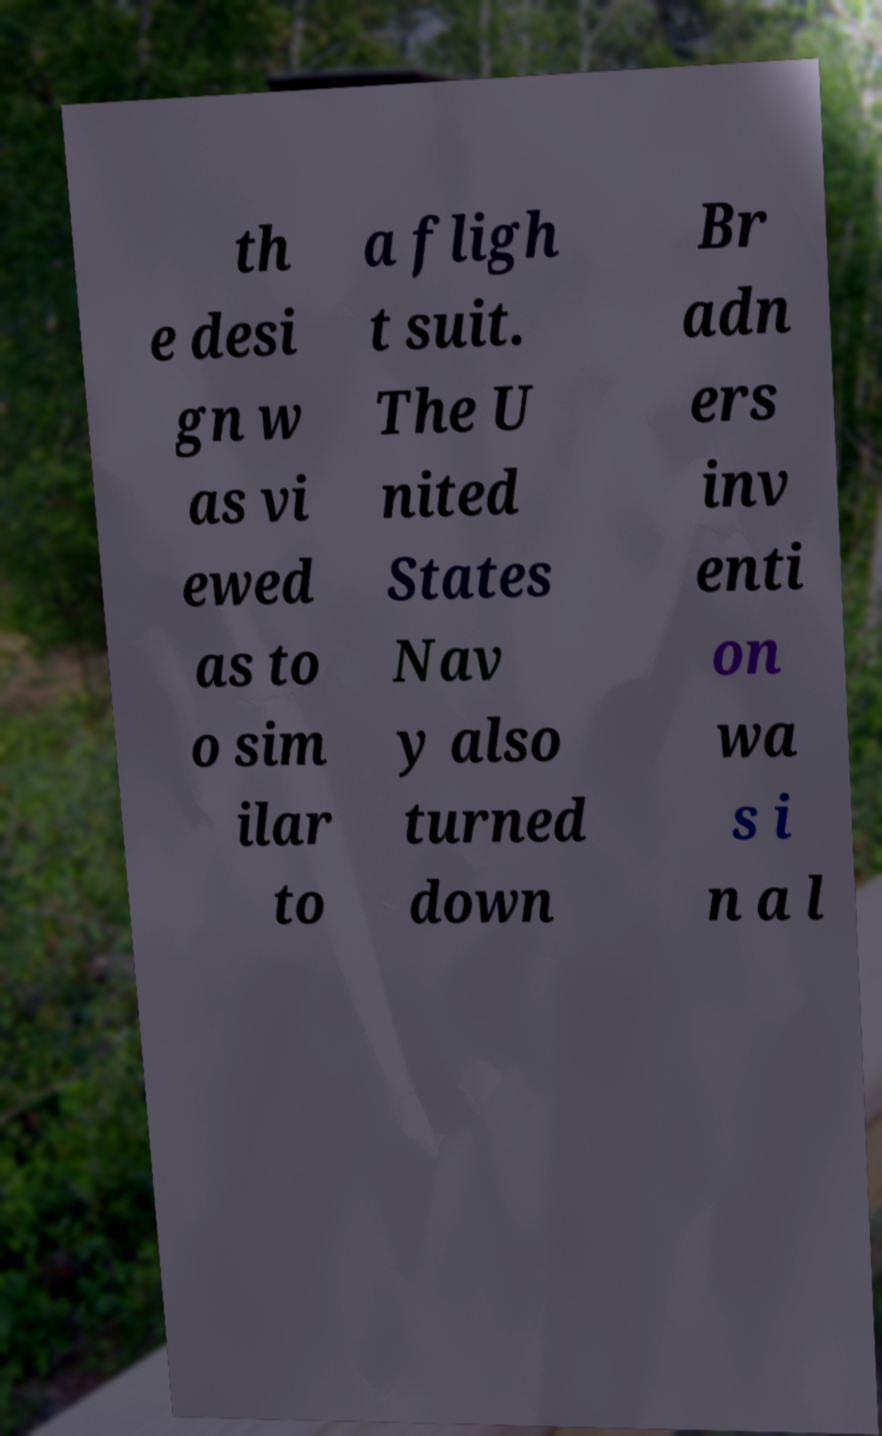Can you read and provide the text displayed in the image?This photo seems to have some interesting text. Can you extract and type it out for me? th e desi gn w as vi ewed as to o sim ilar to a fligh t suit. The U nited States Nav y also turned down Br adn ers inv enti on wa s i n a l 